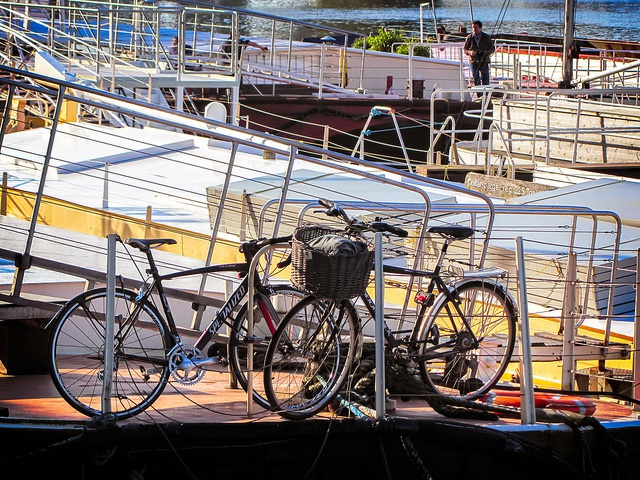Describe the objects in this image and their specific colors. I can see boat in gray, white, darkgray, and tan tones, bicycle in gray, black, darkgray, and lightgray tones, boat in gray, black, maroon, and darkgray tones, bicycle in gray, black, khaki, and darkgray tones, and people in gray, black, maroon, and brown tones in this image. 